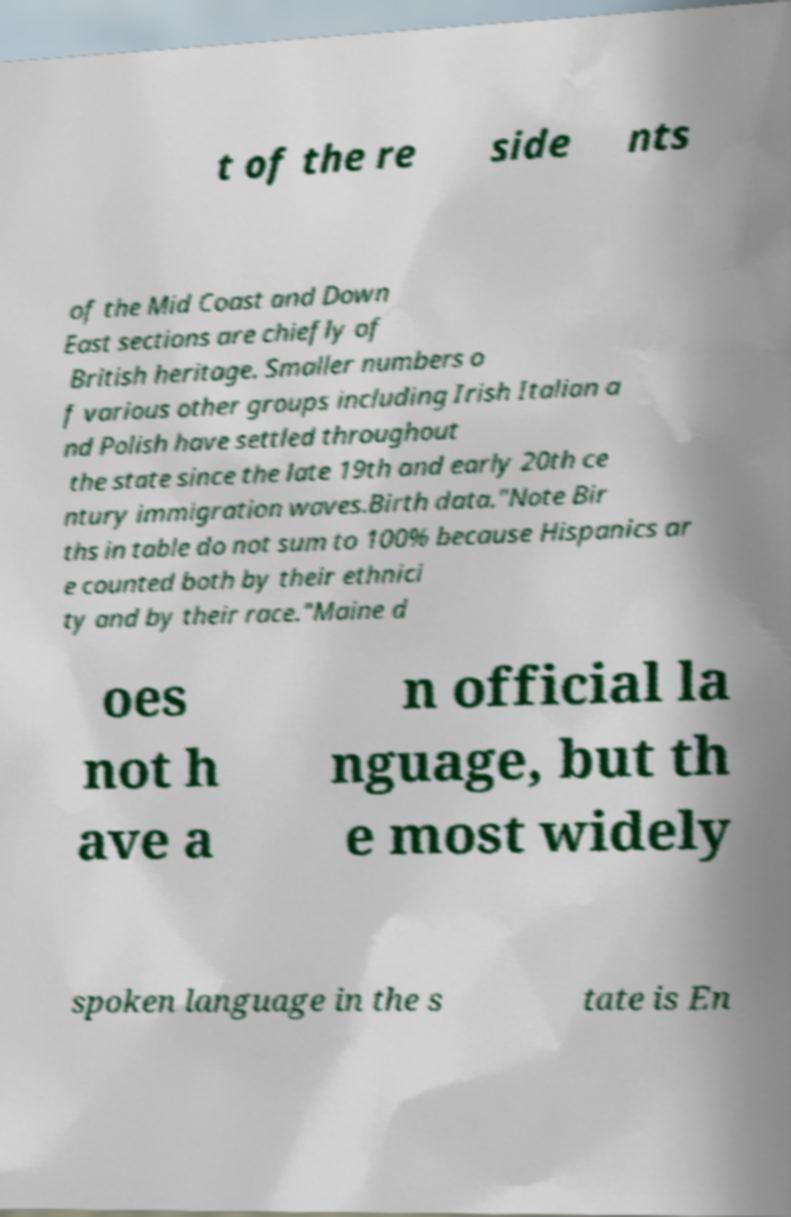Could you extract and type out the text from this image? t of the re side nts of the Mid Coast and Down East sections are chiefly of British heritage. Smaller numbers o f various other groups including Irish Italian a nd Polish have settled throughout the state since the late 19th and early 20th ce ntury immigration waves.Birth data."Note Bir ths in table do not sum to 100% because Hispanics ar e counted both by their ethnici ty and by their race."Maine d oes not h ave a n official la nguage, but th e most widely spoken language in the s tate is En 